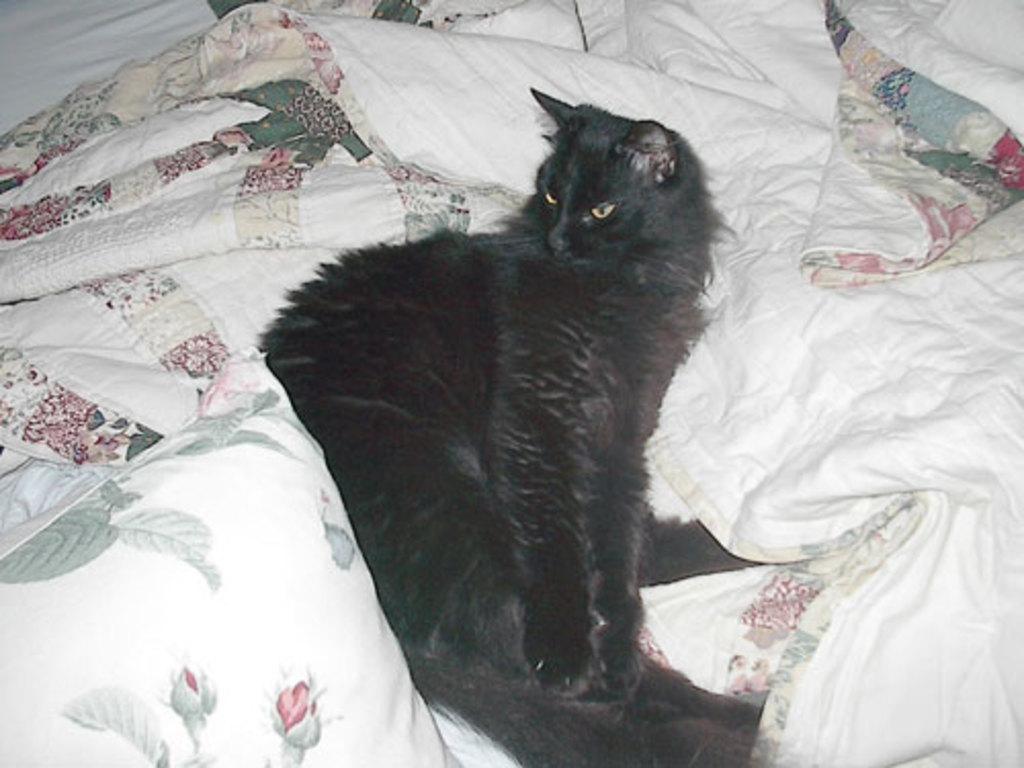How would you summarize this image in a sentence or two? There is a black cat sitting on a white bed sheet. 